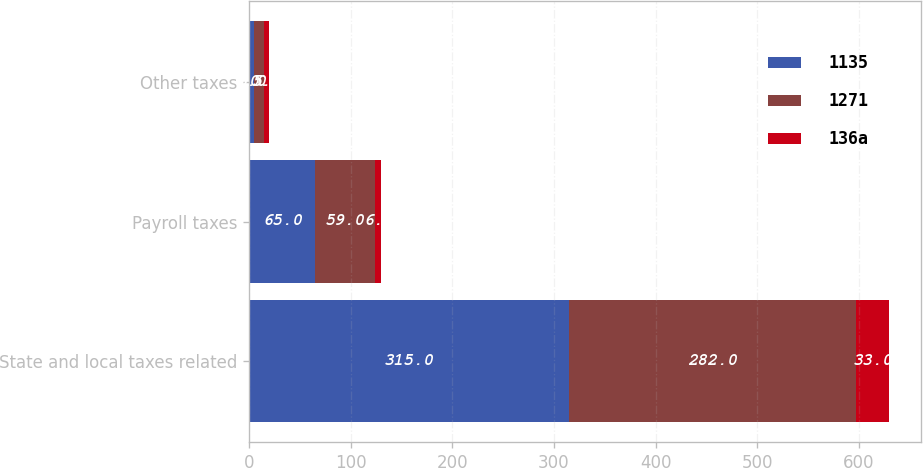Convert chart to OTSL. <chart><loc_0><loc_0><loc_500><loc_500><stacked_bar_chart><ecel><fcel>State and local taxes related<fcel>Payroll taxes<fcel>Other taxes<nl><fcel>1135<fcel>315<fcel>65<fcel>5<nl><fcel>1271<fcel>282<fcel>59<fcel>10<nl><fcel>136a<fcel>33<fcel>6<fcel>5<nl></chart> 